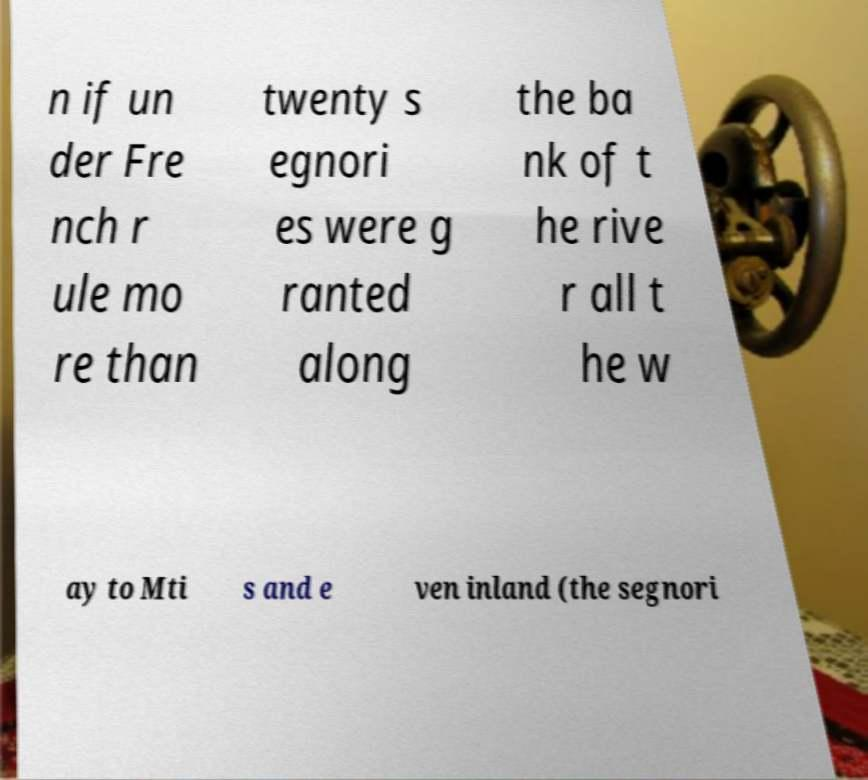What messages or text are displayed in this image? I need them in a readable, typed format. n if un der Fre nch r ule mo re than twenty s egnori es were g ranted along the ba nk of t he rive r all t he w ay to Mti s and e ven inland (the segnori 